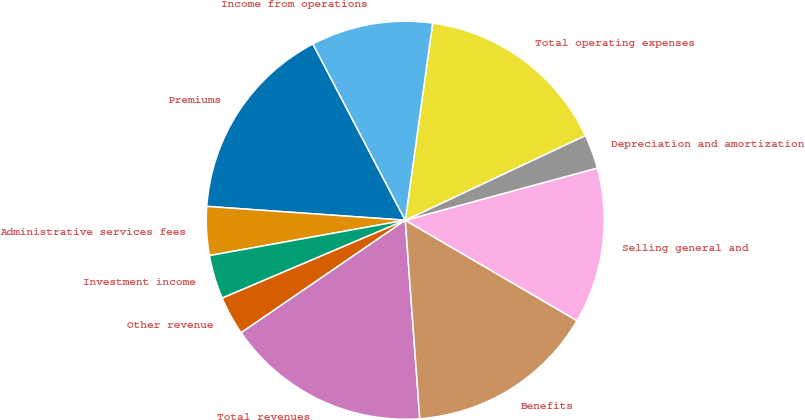Convert chart. <chart><loc_0><loc_0><loc_500><loc_500><pie_chart><fcel>Premiums<fcel>Administrative services fees<fcel>Investment income<fcel>Other revenue<fcel>Total revenues<fcel>Benefits<fcel>Selling general and<fcel>Depreciation and amortization<fcel>Total operating expenses<fcel>Income from operations<nl><fcel>16.21%<fcel>3.95%<fcel>3.56%<fcel>3.16%<fcel>16.6%<fcel>15.42%<fcel>12.65%<fcel>2.77%<fcel>15.81%<fcel>9.88%<nl></chart> 